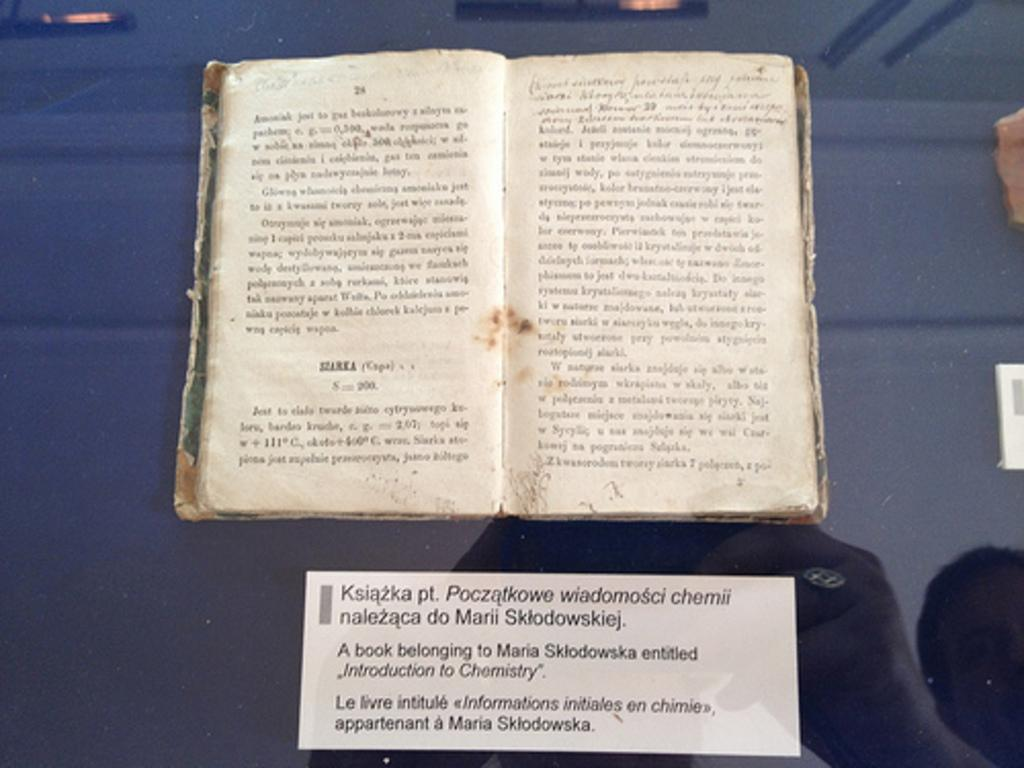<image>
Describe the image concisely. A book opened to page 24 and 25 and a piece of paper beneath it. 